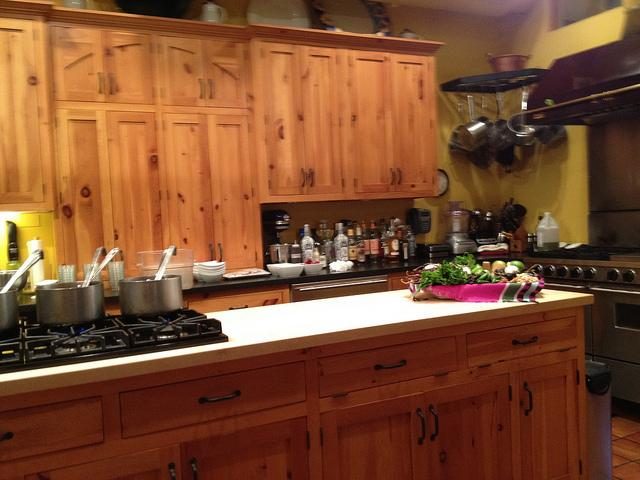What is the object called which is supporting the stove? Please explain your reasoning. island. There is a industrial stove on top of a kitchen center piece. people can walk on all sides of this piece of furniture. 